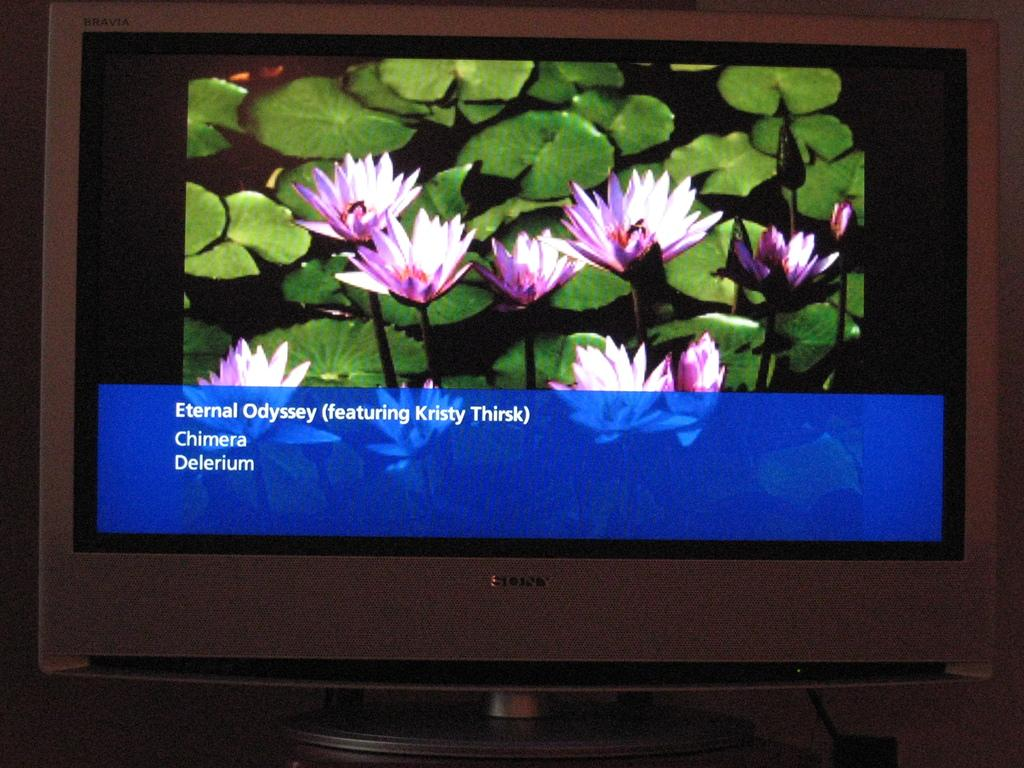What is the main object in the image? There is a television in the image. What is being displayed on the television? The television is displaying flowers and leaves. Is there any text visible on the television? Yes, there is text visible on the television. How many fingers are visible on the television screen? There are no fingers visible on the television screen; it is displaying flowers, leaves, and text. 